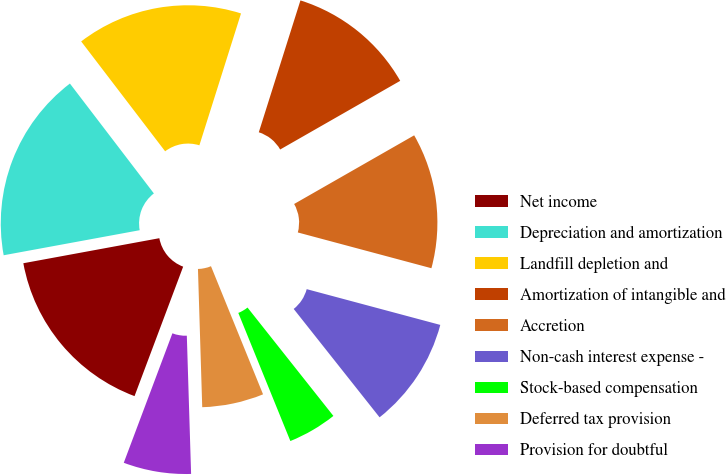<chart> <loc_0><loc_0><loc_500><loc_500><pie_chart><fcel>Net income<fcel>Depreciation and amortization<fcel>Landfill depletion and<fcel>Amortization of intangible and<fcel>Accretion<fcel>Non-cash interest expense -<fcel>Stock-based compensation<fcel>Deferred tax provision<fcel>Provision for doubtful<nl><fcel>16.38%<fcel>17.51%<fcel>15.25%<fcel>11.86%<fcel>12.43%<fcel>10.17%<fcel>4.52%<fcel>5.65%<fcel>6.21%<nl></chart> 